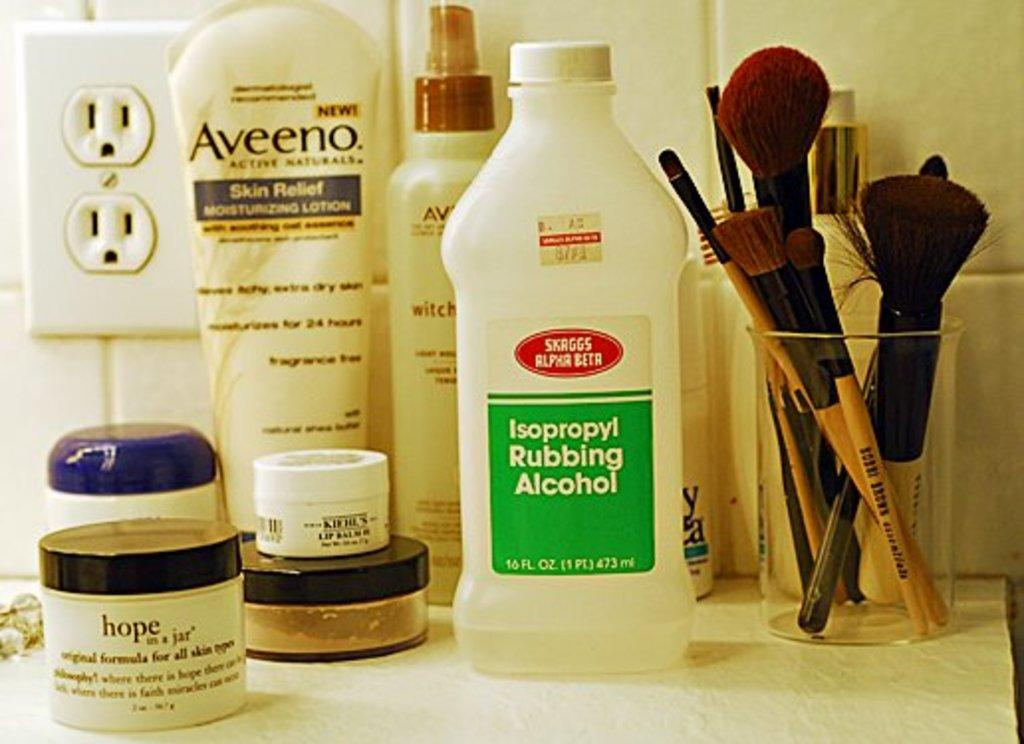What type of products can be seen in the image? There are soap products, lotions, and makeup powders in the image. What tools are present in the image? There are brushes in the image. Where are these items located? All these items are on a table. What type of vegetable is being used as a stage prop in the image? There is no vegetable or stage present in the image; it features soap products, lotions, makeup powders, and brushes are on the table. 